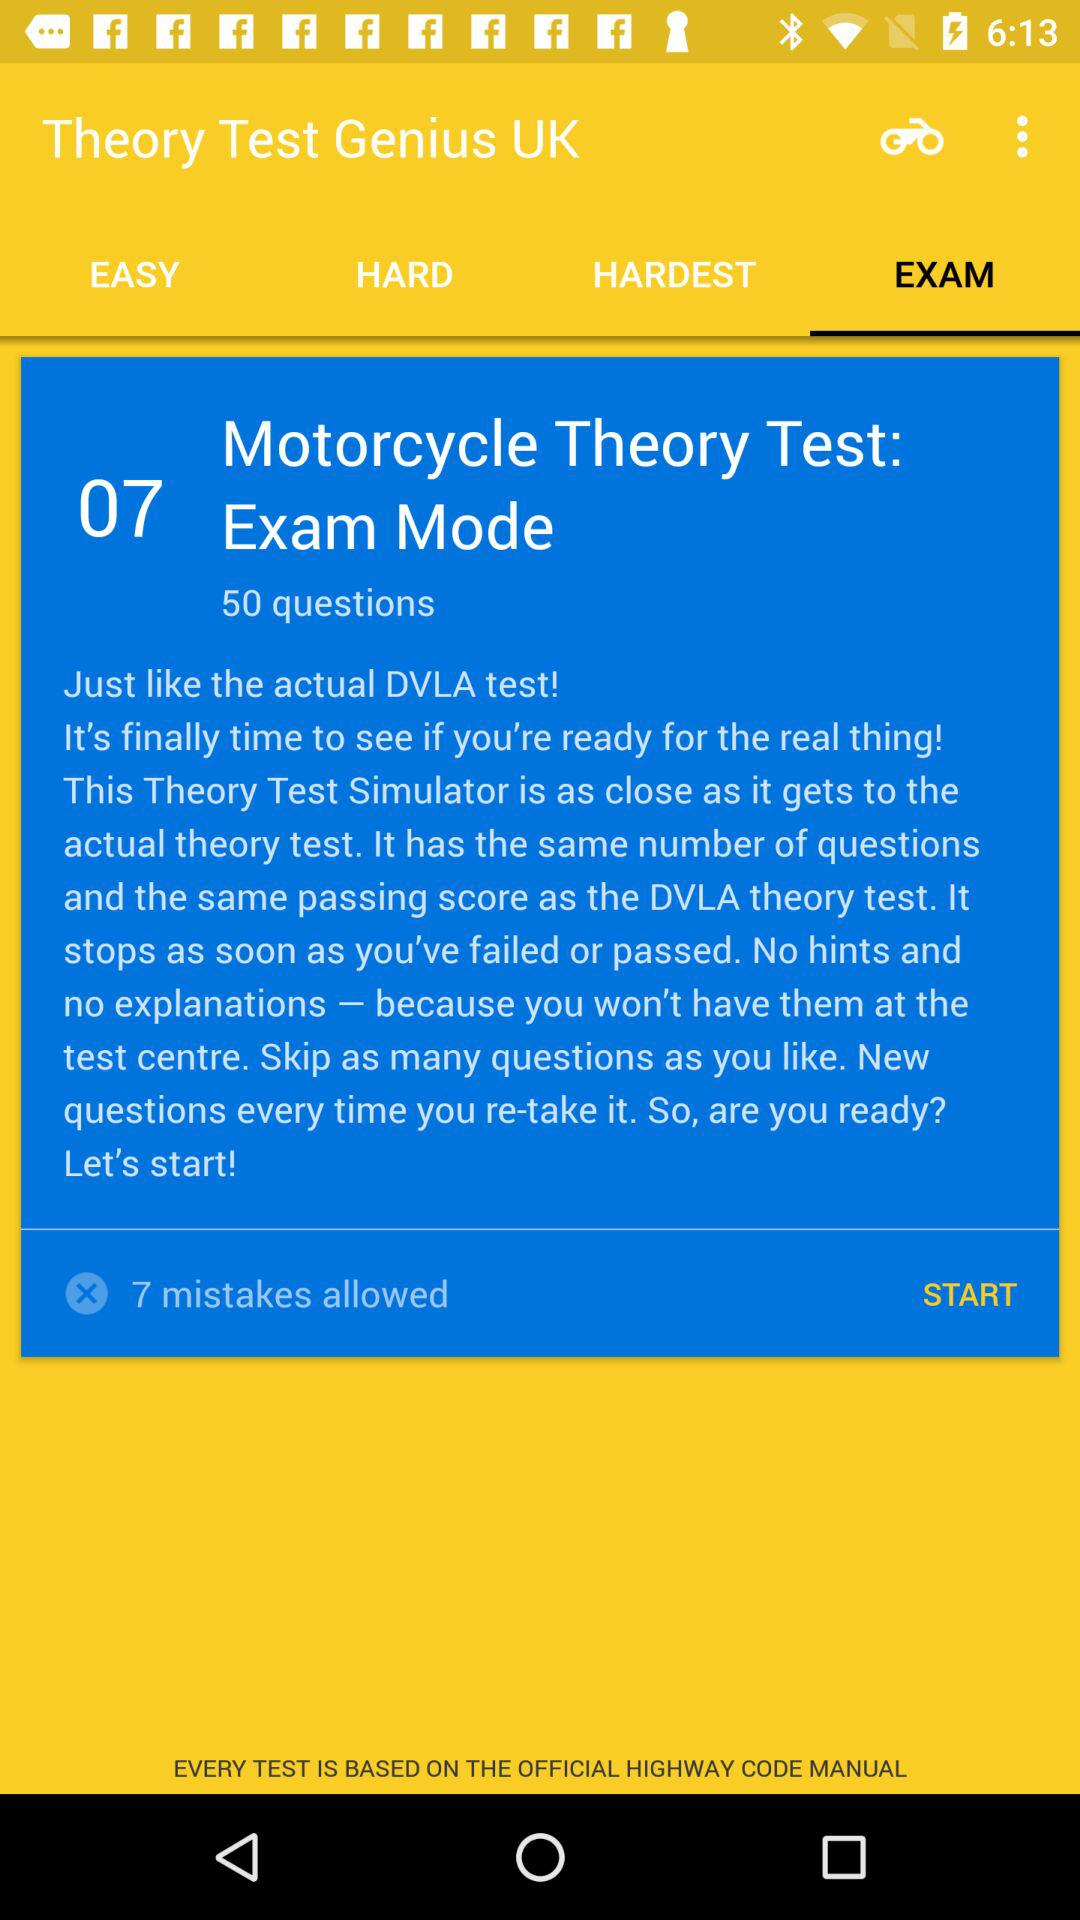How many mistakes are allowed? The number of mistakes allowed is 7. 